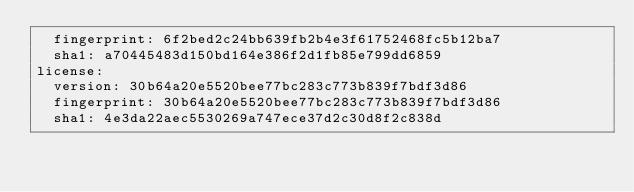Convert code to text. <code><loc_0><loc_0><loc_500><loc_500><_YAML_>  fingerprint: 6f2bed2c24bb639fb2b4e3f61752468fc5b12ba7
  sha1: a70445483d150bd164e386f2d1fb85e799dd6859
license:
  version: 30b64a20e5520bee77bc283c773b839f7bdf3d86
  fingerprint: 30b64a20e5520bee77bc283c773b839f7bdf3d86
  sha1: 4e3da22aec5530269a747ece37d2c30d8f2c838d
</code> 